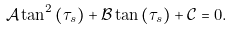Convert formula to latex. <formula><loc_0><loc_0><loc_500><loc_500>\mathcal { A } \tan ^ { 2 } \left ( \tau _ { s } \right ) + \mathcal { B } \tan \left ( \tau _ { s } \right ) + \mathcal { C } = 0 .</formula> 